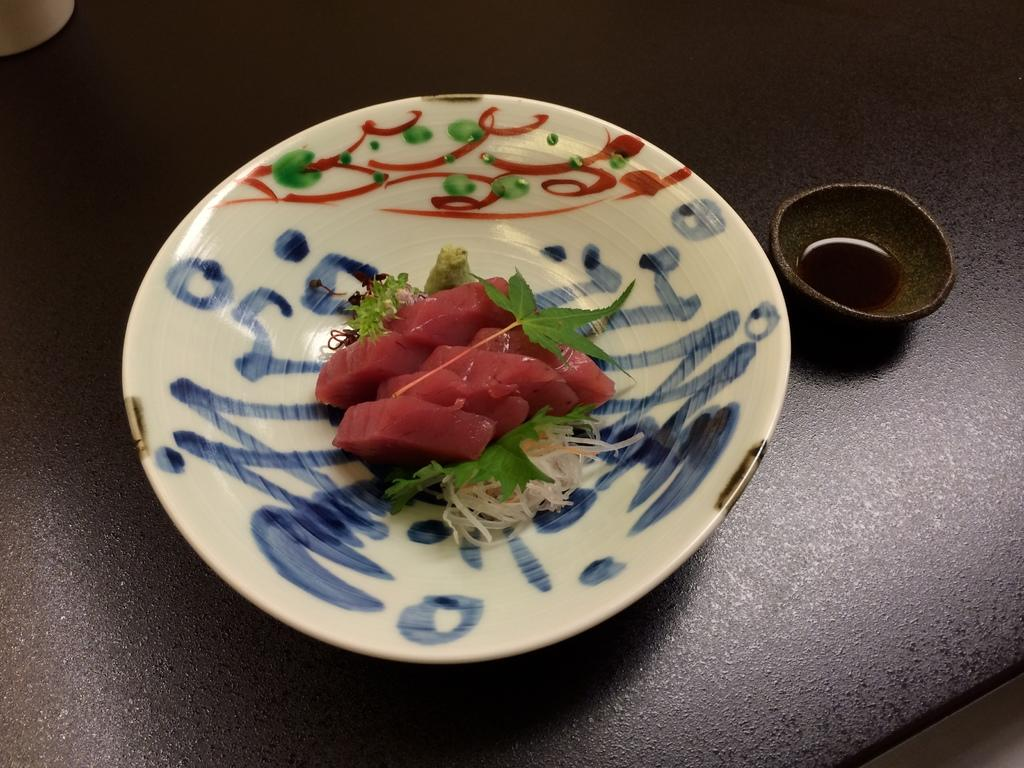What is on the plate in the image? There are food items on a plate in the image. What else can be seen on the table in the image? There are other objects on the table in the image. Can you see any cakes floating on the lake in the image? There is no lake or cakes present in the image. What type of event is taking place in the image? The image does not depict any specific event; it only shows food items on a plate and other objects on a table. 